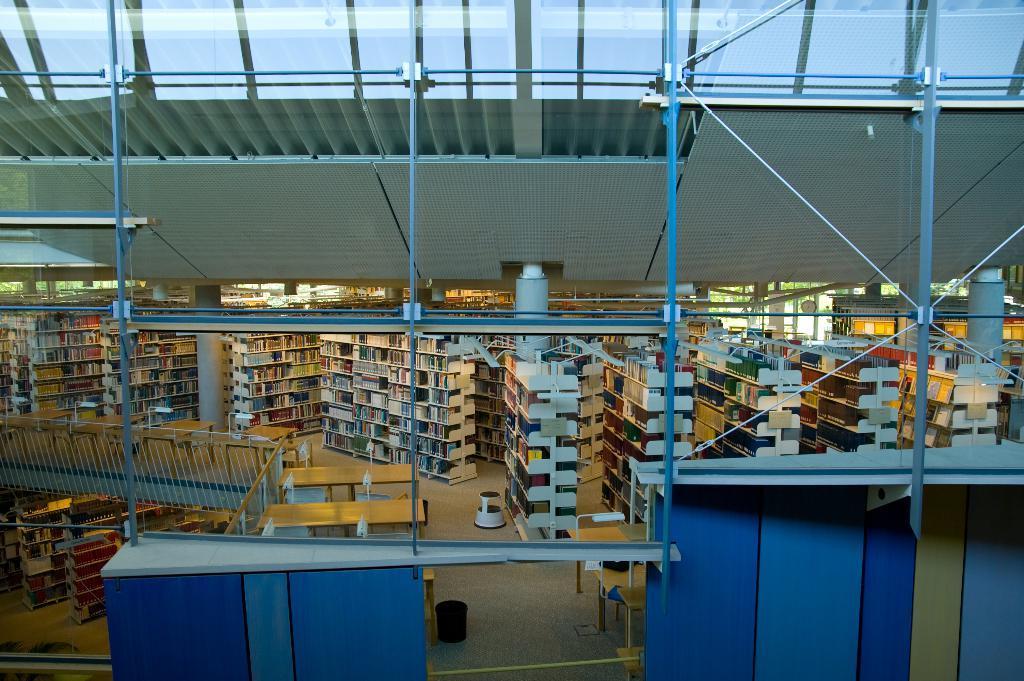In one or two sentences, can you explain what this image depicts? In this picture I can see a number of books and the shelf's. I can see tables. 